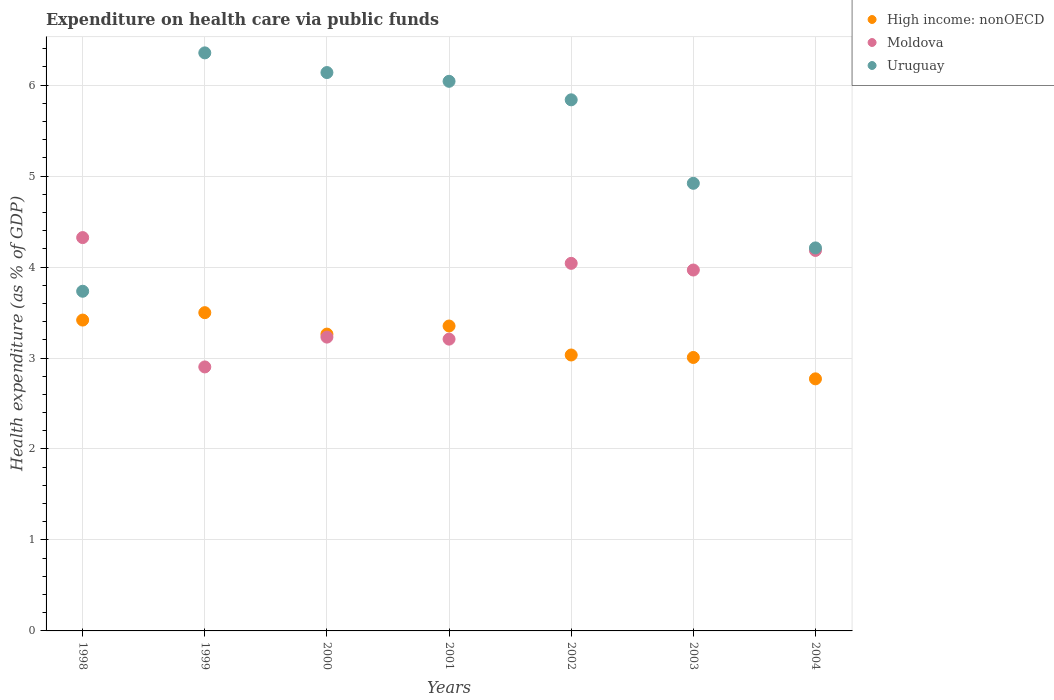What is the expenditure made on health care in Moldova in 2002?
Provide a short and direct response. 4.04. Across all years, what is the maximum expenditure made on health care in Uruguay?
Offer a terse response. 6.35. Across all years, what is the minimum expenditure made on health care in Moldova?
Provide a succinct answer. 2.9. In which year was the expenditure made on health care in Uruguay maximum?
Provide a short and direct response. 1999. In which year was the expenditure made on health care in Moldova minimum?
Give a very brief answer. 1999. What is the total expenditure made on health care in Moldova in the graph?
Your answer should be compact. 25.85. What is the difference between the expenditure made on health care in Uruguay in 2001 and that in 2003?
Provide a short and direct response. 1.12. What is the difference between the expenditure made on health care in High income: nonOECD in 2002 and the expenditure made on health care in Moldova in 2000?
Ensure brevity in your answer.  -0.2. What is the average expenditure made on health care in High income: nonOECD per year?
Offer a terse response. 3.19. In the year 2003, what is the difference between the expenditure made on health care in Uruguay and expenditure made on health care in Moldova?
Provide a succinct answer. 0.95. What is the ratio of the expenditure made on health care in Uruguay in 1998 to that in 2001?
Your response must be concise. 0.62. Is the expenditure made on health care in Moldova in 2001 less than that in 2002?
Keep it short and to the point. Yes. Is the difference between the expenditure made on health care in Uruguay in 1999 and 2003 greater than the difference between the expenditure made on health care in Moldova in 1999 and 2003?
Provide a short and direct response. Yes. What is the difference between the highest and the second highest expenditure made on health care in High income: nonOECD?
Provide a short and direct response. 0.08. What is the difference between the highest and the lowest expenditure made on health care in High income: nonOECD?
Provide a short and direct response. 0.73. In how many years, is the expenditure made on health care in Moldova greater than the average expenditure made on health care in Moldova taken over all years?
Make the answer very short. 4. Is the expenditure made on health care in Uruguay strictly greater than the expenditure made on health care in High income: nonOECD over the years?
Offer a very short reply. Yes. How many years are there in the graph?
Your answer should be compact. 7. What is the difference between two consecutive major ticks on the Y-axis?
Provide a succinct answer. 1. Does the graph contain grids?
Offer a very short reply. Yes. Where does the legend appear in the graph?
Provide a short and direct response. Top right. How many legend labels are there?
Your answer should be very brief. 3. What is the title of the graph?
Your answer should be very brief. Expenditure on health care via public funds. Does "Brunei Darussalam" appear as one of the legend labels in the graph?
Ensure brevity in your answer.  No. What is the label or title of the X-axis?
Offer a terse response. Years. What is the label or title of the Y-axis?
Offer a terse response. Health expenditure (as % of GDP). What is the Health expenditure (as % of GDP) of High income: nonOECD in 1998?
Provide a short and direct response. 3.42. What is the Health expenditure (as % of GDP) of Moldova in 1998?
Offer a very short reply. 4.32. What is the Health expenditure (as % of GDP) in Uruguay in 1998?
Ensure brevity in your answer.  3.73. What is the Health expenditure (as % of GDP) of High income: nonOECD in 1999?
Provide a succinct answer. 3.5. What is the Health expenditure (as % of GDP) in Moldova in 1999?
Offer a terse response. 2.9. What is the Health expenditure (as % of GDP) of Uruguay in 1999?
Offer a terse response. 6.35. What is the Health expenditure (as % of GDP) of High income: nonOECD in 2000?
Make the answer very short. 3.26. What is the Health expenditure (as % of GDP) in Moldova in 2000?
Provide a succinct answer. 3.23. What is the Health expenditure (as % of GDP) of Uruguay in 2000?
Give a very brief answer. 6.14. What is the Health expenditure (as % of GDP) in High income: nonOECD in 2001?
Offer a very short reply. 3.35. What is the Health expenditure (as % of GDP) of Moldova in 2001?
Provide a short and direct response. 3.21. What is the Health expenditure (as % of GDP) of Uruguay in 2001?
Your response must be concise. 6.04. What is the Health expenditure (as % of GDP) of High income: nonOECD in 2002?
Offer a terse response. 3.03. What is the Health expenditure (as % of GDP) of Moldova in 2002?
Keep it short and to the point. 4.04. What is the Health expenditure (as % of GDP) of Uruguay in 2002?
Provide a short and direct response. 5.84. What is the Health expenditure (as % of GDP) in High income: nonOECD in 2003?
Provide a short and direct response. 3.01. What is the Health expenditure (as % of GDP) in Moldova in 2003?
Your answer should be very brief. 3.97. What is the Health expenditure (as % of GDP) of Uruguay in 2003?
Keep it short and to the point. 4.92. What is the Health expenditure (as % of GDP) of High income: nonOECD in 2004?
Offer a very short reply. 2.77. What is the Health expenditure (as % of GDP) in Moldova in 2004?
Your response must be concise. 4.18. What is the Health expenditure (as % of GDP) of Uruguay in 2004?
Give a very brief answer. 4.21. Across all years, what is the maximum Health expenditure (as % of GDP) in High income: nonOECD?
Give a very brief answer. 3.5. Across all years, what is the maximum Health expenditure (as % of GDP) in Moldova?
Offer a very short reply. 4.32. Across all years, what is the maximum Health expenditure (as % of GDP) of Uruguay?
Give a very brief answer. 6.35. Across all years, what is the minimum Health expenditure (as % of GDP) of High income: nonOECD?
Your response must be concise. 2.77. Across all years, what is the minimum Health expenditure (as % of GDP) in Moldova?
Give a very brief answer. 2.9. Across all years, what is the minimum Health expenditure (as % of GDP) in Uruguay?
Your response must be concise. 3.73. What is the total Health expenditure (as % of GDP) of High income: nonOECD in the graph?
Your answer should be very brief. 22.34. What is the total Health expenditure (as % of GDP) in Moldova in the graph?
Keep it short and to the point. 25.85. What is the total Health expenditure (as % of GDP) of Uruguay in the graph?
Your answer should be very brief. 37.24. What is the difference between the Health expenditure (as % of GDP) in High income: nonOECD in 1998 and that in 1999?
Give a very brief answer. -0.08. What is the difference between the Health expenditure (as % of GDP) in Moldova in 1998 and that in 1999?
Give a very brief answer. 1.42. What is the difference between the Health expenditure (as % of GDP) in Uruguay in 1998 and that in 1999?
Your response must be concise. -2.62. What is the difference between the Health expenditure (as % of GDP) in High income: nonOECD in 1998 and that in 2000?
Offer a very short reply. 0.15. What is the difference between the Health expenditure (as % of GDP) in Moldova in 1998 and that in 2000?
Your response must be concise. 1.09. What is the difference between the Health expenditure (as % of GDP) in Uruguay in 1998 and that in 2000?
Offer a terse response. -2.4. What is the difference between the Health expenditure (as % of GDP) in High income: nonOECD in 1998 and that in 2001?
Offer a terse response. 0.07. What is the difference between the Health expenditure (as % of GDP) in Moldova in 1998 and that in 2001?
Your answer should be very brief. 1.12. What is the difference between the Health expenditure (as % of GDP) in Uruguay in 1998 and that in 2001?
Give a very brief answer. -2.31. What is the difference between the Health expenditure (as % of GDP) of High income: nonOECD in 1998 and that in 2002?
Your answer should be very brief. 0.38. What is the difference between the Health expenditure (as % of GDP) in Moldova in 1998 and that in 2002?
Provide a short and direct response. 0.28. What is the difference between the Health expenditure (as % of GDP) of Uruguay in 1998 and that in 2002?
Your answer should be very brief. -2.1. What is the difference between the Health expenditure (as % of GDP) in High income: nonOECD in 1998 and that in 2003?
Keep it short and to the point. 0.41. What is the difference between the Health expenditure (as % of GDP) of Moldova in 1998 and that in 2003?
Provide a succinct answer. 0.36. What is the difference between the Health expenditure (as % of GDP) of Uruguay in 1998 and that in 2003?
Provide a succinct answer. -1.19. What is the difference between the Health expenditure (as % of GDP) in High income: nonOECD in 1998 and that in 2004?
Make the answer very short. 0.65. What is the difference between the Health expenditure (as % of GDP) in Moldova in 1998 and that in 2004?
Provide a short and direct response. 0.14. What is the difference between the Health expenditure (as % of GDP) in Uruguay in 1998 and that in 2004?
Ensure brevity in your answer.  -0.48. What is the difference between the Health expenditure (as % of GDP) of High income: nonOECD in 1999 and that in 2000?
Your response must be concise. 0.24. What is the difference between the Health expenditure (as % of GDP) in Moldova in 1999 and that in 2000?
Offer a terse response. -0.33. What is the difference between the Health expenditure (as % of GDP) in Uruguay in 1999 and that in 2000?
Give a very brief answer. 0.22. What is the difference between the Health expenditure (as % of GDP) in High income: nonOECD in 1999 and that in 2001?
Provide a succinct answer. 0.15. What is the difference between the Health expenditure (as % of GDP) of Moldova in 1999 and that in 2001?
Provide a short and direct response. -0.31. What is the difference between the Health expenditure (as % of GDP) of Uruguay in 1999 and that in 2001?
Ensure brevity in your answer.  0.31. What is the difference between the Health expenditure (as % of GDP) of High income: nonOECD in 1999 and that in 2002?
Provide a short and direct response. 0.47. What is the difference between the Health expenditure (as % of GDP) in Moldova in 1999 and that in 2002?
Provide a short and direct response. -1.14. What is the difference between the Health expenditure (as % of GDP) in Uruguay in 1999 and that in 2002?
Your response must be concise. 0.52. What is the difference between the Health expenditure (as % of GDP) in High income: nonOECD in 1999 and that in 2003?
Give a very brief answer. 0.49. What is the difference between the Health expenditure (as % of GDP) of Moldova in 1999 and that in 2003?
Offer a very short reply. -1.07. What is the difference between the Health expenditure (as % of GDP) in Uruguay in 1999 and that in 2003?
Make the answer very short. 1.43. What is the difference between the Health expenditure (as % of GDP) in High income: nonOECD in 1999 and that in 2004?
Keep it short and to the point. 0.73. What is the difference between the Health expenditure (as % of GDP) in Moldova in 1999 and that in 2004?
Your answer should be compact. -1.28. What is the difference between the Health expenditure (as % of GDP) in Uruguay in 1999 and that in 2004?
Offer a very short reply. 2.14. What is the difference between the Health expenditure (as % of GDP) in High income: nonOECD in 2000 and that in 2001?
Give a very brief answer. -0.09. What is the difference between the Health expenditure (as % of GDP) in Moldova in 2000 and that in 2001?
Give a very brief answer. 0.02. What is the difference between the Health expenditure (as % of GDP) in Uruguay in 2000 and that in 2001?
Give a very brief answer. 0.1. What is the difference between the Health expenditure (as % of GDP) of High income: nonOECD in 2000 and that in 2002?
Keep it short and to the point. 0.23. What is the difference between the Health expenditure (as % of GDP) in Moldova in 2000 and that in 2002?
Provide a succinct answer. -0.81. What is the difference between the Health expenditure (as % of GDP) of Uruguay in 2000 and that in 2002?
Provide a short and direct response. 0.3. What is the difference between the Health expenditure (as % of GDP) in High income: nonOECD in 2000 and that in 2003?
Your answer should be compact. 0.26. What is the difference between the Health expenditure (as % of GDP) of Moldova in 2000 and that in 2003?
Offer a very short reply. -0.74. What is the difference between the Health expenditure (as % of GDP) of Uruguay in 2000 and that in 2003?
Provide a short and direct response. 1.22. What is the difference between the Health expenditure (as % of GDP) of High income: nonOECD in 2000 and that in 2004?
Make the answer very short. 0.49. What is the difference between the Health expenditure (as % of GDP) in Moldova in 2000 and that in 2004?
Your response must be concise. -0.95. What is the difference between the Health expenditure (as % of GDP) in Uruguay in 2000 and that in 2004?
Provide a short and direct response. 1.93. What is the difference between the Health expenditure (as % of GDP) in High income: nonOECD in 2001 and that in 2002?
Your answer should be very brief. 0.32. What is the difference between the Health expenditure (as % of GDP) of Moldova in 2001 and that in 2002?
Your answer should be compact. -0.83. What is the difference between the Health expenditure (as % of GDP) of Uruguay in 2001 and that in 2002?
Ensure brevity in your answer.  0.2. What is the difference between the Health expenditure (as % of GDP) of High income: nonOECD in 2001 and that in 2003?
Give a very brief answer. 0.35. What is the difference between the Health expenditure (as % of GDP) of Moldova in 2001 and that in 2003?
Provide a succinct answer. -0.76. What is the difference between the Health expenditure (as % of GDP) in Uruguay in 2001 and that in 2003?
Offer a terse response. 1.12. What is the difference between the Health expenditure (as % of GDP) in High income: nonOECD in 2001 and that in 2004?
Keep it short and to the point. 0.58. What is the difference between the Health expenditure (as % of GDP) in Moldova in 2001 and that in 2004?
Ensure brevity in your answer.  -0.97. What is the difference between the Health expenditure (as % of GDP) in Uruguay in 2001 and that in 2004?
Your response must be concise. 1.83. What is the difference between the Health expenditure (as % of GDP) in High income: nonOECD in 2002 and that in 2003?
Your answer should be compact. 0.03. What is the difference between the Health expenditure (as % of GDP) in Moldova in 2002 and that in 2003?
Your answer should be compact. 0.07. What is the difference between the Health expenditure (as % of GDP) of Uruguay in 2002 and that in 2003?
Your answer should be very brief. 0.92. What is the difference between the Health expenditure (as % of GDP) in High income: nonOECD in 2002 and that in 2004?
Give a very brief answer. 0.26. What is the difference between the Health expenditure (as % of GDP) of Moldova in 2002 and that in 2004?
Provide a succinct answer. -0.14. What is the difference between the Health expenditure (as % of GDP) in Uruguay in 2002 and that in 2004?
Make the answer very short. 1.63. What is the difference between the Health expenditure (as % of GDP) in High income: nonOECD in 2003 and that in 2004?
Offer a very short reply. 0.23. What is the difference between the Health expenditure (as % of GDP) in Moldova in 2003 and that in 2004?
Offer a terse response. -0.22. What is the difference between the Health expenditure (as % of GDP) of Uruguay in 2003 and that in 2004?
Offer a very short reply. 0.71. What is the difference between the Health expenditure (as % of GDP) in High income: nonOECD in 1998 and the Health expenditure (as % of GDP) in Moldova in 1999?
Your answer should be very brief. 0.52. What is the difference between the Health expenditure (as % of GDP) in High income: nonOECD in 1998 and the Health expenditure (as % of GDP) in Uruguay in 1999?
Keep it short and to the point. -2.94. What is the difference between the Health expenditure (as % of GDP) of Moldova in 1998 and the Health expenditure (as % of GDP) of Uruguay in 1999?
Your answer should be compact. -2.03. What is the difference between the Health expenditure (as % of GDP) of High income: nonOECD in 1998 and the Health expenditure (as % of GDP) of Moldova in 2000?
Give a very brief answer. 0.19. What is the difference between the Health expenditure (as % of GDP) of High income: nonOECD in 1998 and the Health expenditure (as % of GDP) of Uruguay in 2000?
Your answer should be very brief. -2.72. What is the difference between the Health expenditure (as % of GDP) in Moldova in 1998 and the Health expenditure (as % of GDP) in Uruguay in 2000?
Provide a short and direct response. -1.81. What is the difference between the Health expenditure (as % of GDP) in High income: nonOECD in 1998 and the Health expenditure (as % of GDP) in Moldova in 2001?
Offer a very short reply. 0.21. What is the difference between the Health expenditure (as % of GDP) in High income: nonOECD in 1998 and the Health expenditure (as % of GDP) in Uruguay in 2001?
Offer a terse response. -2.62. What is the difference between the Health expenditure (as % of GDP) of Moldova in 1998 and the Health expenditure (as % of GDP) of Uruguay in 2001?
Make the answer very short. -1.72. What is the difference between the Health expenditure (as % of GDP) in High income: nonOECD in 1998 and the Health expenditure (as % of GDP) in Moldova in 2002?
Ensure brevity in your answer.  -0.62. What is the difference between the Health expenditure (as % of GDP) in High income: nonOECD in 1998 and the Health expenditure (as % of GDP) in Uruguay in 2002?
Provide a succinct answer. -2.42. What is the difference between the Health expenditure (as % of GDP) of Moldova in 1998 and the Health expenditure (as % of GDP) of Uruguay in 2002?
Your response must be concise. -1.51. What is the difference between the Health expenditure (as % of GDP) of High income: nonOECD in 1998 and the Health expenditure (as % of GDP) of Moldova in 2003?
Provide a short and direct response. -0.55. What is the difference between the Health expenditure (as % of GDP) of High income: nonOECD in 1998 and the Health expenditure (as % of GDP) of Uruguay in 2003?
Make the answer very short. -1.5. What is the difference between the Health expenditure (as % of GDP) in Moldova in 1998 and the Health expenditure (as % of GDP) in Uruguay in 2003?
Provide a short and direct response. -0.6. What is the difference between the Health expenditure (as % of GDP) in High income: nonOECD in 1998 and the Health expenditure (as % of GDP) in Moldova in 2004?
Your response must be concise. -0.77. What is the difference between the Health expenditure (as % of GDP) of High income: nonOECD in 1998 and the Health expenditure (as % of GDP) of Uruguay in 2004?
Make the answer very short. -0.79. What is the difference between the Health expenditure (as % of GDP) in Moldova in 1998 and the Health expenditure (as % of GDP) in Uruguay in 2004?
Ensure brevity in your answer.  0.11. What is the difference between the Health expenditure (as % of GDP) in High income: nonOECD in 1999 and the Health expenditure (as % of GDP) in Moldova in 2000?
Give a very brief answer. 0.27. What is the difference between the Health expenditure (as % of GDP) in High income: nonOECD in 1999 and the Health expenditure (as % of GDP) in Uruguay in 2000?
Keep it short and to the point. -2.64. What is the difference between the Health expenditure (as % of GDP) of Moldova in 1999 and the Health expenditure (as % of GDP) of Uruguay in 2000?
Offer a terse response. -3.24. What is the difference between the Health expenditure (as % of GDP) of High income: nonOECD in 1999 and the Health expenditure (as % of GDP) of Moldova in 2001?
Keep it short and to the point. 0.29. What is the difference between the Health expenditure (as % of GDP) of High income: nonOECD in 1999 and the Health expenditure (as % of GDP) of Uruguay in 2001?
Provide a short and direct response. -2.54. What is the difference between the Health expenditure (as % of GDP) of Moldova in 1999 and the Health expenditure (as % of GDP) of Uruguay in 2001?
Offer a terse response. -3.14. What is the difference between the Health expenditure (as % of GDP) in High income: nonOECD in 1999 and the Health expenditure (as % of GDP) in Moldova in 2002?
Your answer should be compact. -0.54. What is the difference between the Health expenditure (as % of GDP) in High income: nonOECD in 1999 and the Health expenditure (as % of GDP) in Uruguay in 2002?
Offer a very short reply. -2.34. What is the difference between the Health expenditure (as % of GDP) of Moldova in 1999 and the Health expenditure (as % of GDP) of Uruguay in 2002?
Ensure brevity in your answer.  -2.94. What is the difference between the Health expenditure (as % of GDP) of High income: nonOECD in 1999 and the Health expenditure (as % of GDP) of Moldova in 2003?
Provide a succinct answer. -0.47. What is the difference between the Health expenditure (as % of GDP) in High income: nonOECD in 1999 and the Health expenditure (as % of GDP) in Uruguay in 2003?
Provide a short and direct response. -1.42. What is the difference between the Health expenditure (as % of GDP) of Moldova in 1999 and the Health expenditure (as % of GDP) of Uruguay in 2003?
Provide a short and direct response. -2.02. What is the difference between the Health expenditure (as % of GDP) in High income: nonOECD in 1999 and the Health expenditure (as % of GDP) in Moldova in 2004?
Provide a short and direct response. -0.68. What is the difference between the Health expenditure (as % of GDP) in High income: nonOECD in 1999 and the Health expenditure (as % of GDP) in Uruguay in 2004?
Your answer should be very brief. -0.71. What is the difference between the Health expenditure (as % of GDP) in Moldova in 1999 and the Health expenditure (as % of GDP) in Uruguay in 2004?
Provide a succinct answer. -1.31. What is the difference between the Health expenditure (as % of GDP) in High income: nonOECD in 2000 and the Health expenditure (as % of GDP) in Moldova in 2001?
Your answer should be very brief. 0.06. What is the difference between the Health expenditure (as % of GDP) of High income: nonOECD in 2000 and the Health expenditure (as % of GDP) of Uruguay in 2001?
Your response must be concise. -2.78. What is the difference between the Health expenditure (as % of GDP) of Moldova in 2000 and the Health expenditure (as % of GDP) of Uruguay in 2001?
Your response must be concise. -2.81. What is the difference between the Health expenditure (as % of GDP) of High income: nonOECD in 2000 and the Health expenditure (as % of GDP) of Moldova in 2002?
Your response must be concise. -0.78. What is the difference between the Health expenditure (as % of GDP) of High income: nonOECD in 2000 and the Health expenditure (as % of GDP) of Uruguay in 2002?
Make the answer very short. -2.58. What is the difference between the Health expenditure (as % of GDP) in Moldova in 2000 and the Health expenditure (as % of GDP) in Uruguay in 2002?
Offer a very short reply. -2.61. What is the difference between the Health expenditure (as % of GDP) of High income: nonOECD in 2000 and the Health expenditure (as % of GDP) of Moldova in 2003?
Your answer should be very brief. -0.7. What is the difference between the Health expenditure (as % of GDP) in High income: nonOECD in 2000 and the Health expenditure (as % of GDP) in Uruguay in 2003?
Keep it short and to the point. -1.66. What is the difference between the Health expenditure (as % of GDP) of Moldova in 2000 and the Health expenditure (as % of GDP) of Uruguay in 2003?
Keep it short and to the point. -1.69. What is the difference between the Health expenditure (as % of GDP) in High income: nonOECD in 2000 and the Health expenditure (as % of GDP) in Moldova in 2004?
Keep it short and to the point. -0.92. What is the difference between the Health expenditure (as % of GDP) of High income: nonOECD in 2000 and the Health expenditure (as % of GDP) of Uruguay in 2004?
Your answer should be very brief. -0.95. What is the difference between the Health expenditure (as % of GDP) in Moldova in 2000 and the Health expenditure (as % of GDP) in Uruguay in 2004?
Offer a very short reply. -0.98. What is the difference between the Health expenditure (as % of GDP) in High income: nonOECD in 2001 and the Health expenditure (as % of GDP) in Moldova in 2002?
Offer a very short reply. -0.69. What is the difference between the Health expenditure (as % of GDP) of High income: nonOECD in 2001 and the Health expenditure (as % of GDP) of Uruguay in 2002?
Give a very brief answer. -2.49. What is the difference between the Health expenditure (as % of GDP) in Moldova in 2001 and the Health expenditure (as % of GDP) in Uruguay in 2002?
Ensure brevity in your answer.  -2.63. What is the difference between the Health expenditure (as % of GDP) in High income: nonOECD in 2001 and the Health expenditure (as % of GDP) in Moldova in 2003?
Provide a short and direct response. -0.62. What is the difference between the Health expenditure (as % of GDP) in High income: nonOECD in 2001 and the Health expenditure (as % of GDP) in Uruguay in 2003?
Your response must be concise. -1.57. What is the difference between the Health expenditure (as % of GDP) of Moldova in 2001 and the Health expenditure (as % of GDP) of Uruguay in 2003?
Provide a succinct answer. -1.71. What is the difference between the Health expenditure (as % of GDP) in High income: nonOECD in 2001 and the Health expenditure (as % of GDP) in Moldova in 2004?
Provide a short and direct response. -0.83. What is the difference between the Health expenditure (as % of GDP) of High income: nonOECD in 2001 and the Health expenditure (as % of GDP) of Uruguay in 2004?
Make the answer very short. -0.86. What is the difference between the Health expenditure (as % of GDP) of Moldova in 2001 and the Health expenditure (as % of GDP) of Uruguay in 2004?
Offer a very short reply. -1. What is the difference between the Health expenditure (as % of GDP) of High income: nonOECD in 2002 and the Health expenditure (as % of GDP) of Moldova in 2003?
Provide a succinct answer. -0.93. What is the difference between the Health expenditure (as % of GDP) in High income: nonOECD in 2002 and the Health expenditure (as % of GDP) in Uruguay in 2003?
Your answer should be very brief. -1.89. What is the difference between the Health expenditure (as % of GDP) of Moldova in 2002 and the Health expenditure (as % of GDP) of Uruguay in 2003?
Make the answer very short. -0.88. What is the difference between the Health expenditure (as % of GDP) of High income: nonOECD in 2002 and the Health expenditure (as % of GDP) of Moldova in 2004?
Ensure brevity in your answer.  -1.15. What is the difference between the Health expenditure (as % of GDP) of High income: nonOECD in 2002 and the Health expenditure (as % of GDP) of Uruguay in 2004?
Ensure brevity in your answer.  -1.18. What is the difference between the Health expenditure (as % of GDP) in Moldova in 2002 and the Health expenditure (as % of GDP) in Uruguay in 2004?
Offer a terse response. -0.17. What is the difference between the Health expenditure (as % of GDP) in High income: nonOECD in 2003 and the Health expenditure (as % of GDP) in Moldova in 2004?
Provide a short and direct response. -1.18. What is the difference between the Health expenditure (as % of GDP) in High income: nonOECD in 2003 and the Health expenditure (as % of GDP) in Uruguay in 2004?
Make the answer very short. -1.2. What is the difference between the Health expenditure (as % of GDP) in Moldova in 2003 and the Health expenditure (as % of GDP) in Uruguay in 2004?
Your response must be concise. -0.24. What is the average Health expenditure (as % of GDP) in High income: nonOECD per year?
Ensure brevity in your answer.  3.19. What is the average Health expenditure (as % of GDP) in Moldova per year?
Provide a succinct answer. 3.69. What is the average Health expenditure (as % of GDP) in Uruguay per year?
Ensure brevity in your answer.  5.32. In the year 1998, what is the difference between the Health expenditure (as % of GDP) of High income: nonOECD and Health expenditure (as % of GDP) of Moldova?
Your answer should be very brief. -0.91. In the year 1998, what is the difference between the Health expenditure (as % of GDP) of High income: nonOECD and Health expenditure (as % of GDP) of Uruguay?
Keep it short and to the point. -0.32. In the year 1998, what is the difference between the Health expenditure (as % of GDP) of Moldova and Health expenditure (as % of GDP) of Uruguay?
Make the answer very short. 0.59. In the year 1999, what is the difference between the Health expenditure (as % of GDP) in High income: nonOECD and Health expenditure (as % of GDP) in Moldova?
Provide a succinct answer. 0.6. In the year 1999, what is the difference between the Health expenditure (as % of GDP) of High income: nonOECD and Health expenditure (as % of GDP) of Uruguay?
Provide a short and direct response. -2.86. In the year 1999, what is the difference between the Health expenditure (as % of GDP) of Moldova and Health expenditure (as % of GDP) of Uruguay?
Offer a terse response. -3.45. In the year 2000, what is the difference between the Health expenditure (as % of GDP) in High income: nonOECD and Health expenditure (as % of GDP) in Moldova?
Provide a succinct answer. 0.03. In the year 2000, what is the difference between the Health expenditure (as % of GDP) in High income: nonOECD and Health expenditure (as % of GDP) in Uruguay?
Offer a very short reply. -2.88. In the year 2000, what is the difference between the Health expenditure (as % of GDP) in Moldova and Health expenditure (as % of GDP) in Uruguay?
Give a very brief answer. -2.91. In the year 2001, what is the difference between the Health expenditure (as % of GDP) in High income: nonOECD and Health expenditure (as % of GDP) in Moldova?
Offer a very short reply. 0.14. In the year 2001, what is the difference between the Health expenditure (as % of GDP) of High income: nonOECD and Health expenditure (as % of GDP) of Uruguay?
Your answer should be compact. -2.69. In the year 2001, what is the difference between the Health expenditure (as % of GDP) in Moldova and Health expenditure (as % of GDP) in Uruguay?
Your response must be concise. -2.83. In the year 2002, what is the difference between the Health expenditure (as % of GDP) in High income: nonOECD and Health expenditure (as % of GDP) in Moldova?
Provide a succinct answer. -1.01. In the year 2002, what is the difference between the Health expenditure (as % of GDP) of High income: nonOECD and Health expenditure (as % of GDP) of Uruguay?
Offer a very short reply. -2.81. In the year 2002, what is the difference between the Health expenditure (as % of GDP) of Moldova and Health expenditure (as % of GDP) of Uruguay?
Your response must be concise. -1.8. In the year 2003, what is the difference between the Health expenditure (as % of GDP) of High income: nonOECD and Health expenditure (as % of GDP) of Moldova?
Offer a very short reply. -0.96. In the year 2003, what is the difference between the Health expenditure (as % of GDP) in High income: nonOECD and Health expenditure (as % of GDP) in Uruguay?
Keep it short and to the point. -1.91. In the year 2003, what is the difference between the Health expenditure (as % of GDP) in Moldova and Health expenditure (as % of GDP) in Uruguay?
Ensure brevity in your answer.  -0.95. In the year 2004, what is the difference between the Health expenditure (as % of GDP) of High income: nonOECD and Health expenditure (as % of GDP) of Moldova?
Ensure brevity in your answer.  -1.41. In the year 2004, what is the difference between the Health expenditure (as % of GDP) of High income: nonOECD and Health expenditure (as % of GDP) of Uruguay?
Give a very brief answer. -1.44. In the year 2004, what is the difference between the Health expenditure (as % of GDP) of Moldova and Health expenditure (as % of GDP) of Uruguay?
Provide a short and direct response. -0.03. What is the ratio of the Health expenditure (as % of GDP) in High income: nonOECD in 1998 to that in 1999?
Your answer should be very brief. 0.98. What is the ratio of the Health expenditure (as % of GDP) of Moldova in 1998 to that in 1999?
Your answer should be very brief. 1.49. What is the ratio of the Health expenditure (as % of GDP) of Uruguay in 1998 to that in 1999?
Give a very brief answer. 0.59. What is the ratio of the Health expenditure (as % of GDP) in High income: nonOECD in 1998 to that in 2000?
Provide a short and direct response. 1.05. What is the ratio of the Health expenditure (as % of GDP) of Moldova in 1998 to that in 2000?
Ensure brevity in your answer.  1.34. What is the ratio of the Health expenditure (as % of GDP) of Uruguay in 1998 to that in 2000?
Make the answer very short. 0.61. What is the ratio of the Health expenditure (as % of GDP) of High income: nonOECD in 1998 to that in 2001?
Give a very brief answer. 1.02. What is the ratio of the Health expenditure (as % of GDP) in Moldova in 1998 to that in 2001?
Offer a very short reply. 1.35. What is the ratio of the Health expenditure (as % of GDP) in Uruguay in 1998 to that in 2001?
Offer a terse response. 0.62. What is the ratio of the Health expenditure (as % of GDP) in High income: nonOECD in 1998 to that in 2002?
Your answer should be compact. 1.13. What is the ratio of the Health expenditure (as % of GDP) of Moldova in 1998 to that in 2002?
Your answer should be compact. 1.07. What is the ratio of the Health expenditure (as % of GDP) of Uruguay in 1998 to that in 2002?
Provide a short and direct response. 0.64. What is the ratio of the Health expenditure (as % of GDP) in High income: nonOECD in 1998 to that in 2003?
Provide a succinct answer. 1.14. What is the ratio of the Health expenditure (as % of GDP) in Moldova in 1998 to that in 2003?
Give a very brief answer. 1.09. What is the ratio of the Health expenditure (as % of GDP) in Uruguay in 1998 to that in 2003?
Your answer should be very brief. 0.76. What is the ratio of the Health expenditure (as % of GDP) of High income: nonOECD in 1998 to that in 2004?
Provide a short and direct response. 1.23. What is the ratio of the Health expenditure (as % of GDP) of Moldova in 1998 to that in 2004?
Your response must be concise. 1.03. What is the ratio of the Health expenditure (as % of GDP) in Uruguay in 1998 to that in 2004?
Offer a terse response. 0.89. What is the ratio of the Health expenditure (as % of GDP) in High income: nonOECD in 1999 to that in 2000?
Provide a succinct answer. 1.07. What is the ratio of the Health expenditure (as % of GDP) of Moldova in 1999 to that in 2000?
Your answer should be very brief. 0.9. What is the ratio of the Health expenditure (as % of GDP) in Uruguay in 1999 to that in 2000?
Your answer should be compact. 1.04. What is the ratio of the Health expenditure (as % of GDP) of High income: nonOECD in 1999 to that in 2001?
Offer a terse response. 1.04. What is the ratio of the Health expenditure (as % of GDP) of Moldova in 1999 to that in 2001?
Make the answer very short. 0.9. What is the ratio of the Health expenditure (as % of GDP) of Uruguay in 1999 to that in 2001?
Provide a short and direct response. 1.05. What is the ratio of the Health expenditure (as % of GDP) of High income: nonOECD in 1999 to that in 2002?
Make the answer very short. 1.15. What is the ratio of the Health expenditure (as % of GDP) of Moldova in 1999 to that in 2002?
Your answer should be compact. 0.72. What is the ratio of the Health expenditure (as % of GDP) in Uruguay in 1999 to that in 2002?
Your answer should be very brief. 1.09. What is the ratio of the Health expenditure (as % of GDP) of High income: nonOECD in 1999 to that in 2003?
Ensure brevity in your answer.  1.16. What is the ratio of the Health expenditure (as % of GDP) of Moldova in 1999 to that in 2003?
Give a very brief answer. 0.73. What is the ratio of the Health expenditure (as % of GDP) in Uruguay in 1999 to that in 2003?
Your response must be concise. 1.29. What is the ratio of the Health expenditure (as % of GDP) of High income: nonOECD in 1999 to that in 2004?
Provide a short and direct response. 1.26. What is the ratio of the Health expenditure (as % of GDP) of Moldova in 1999 to that in 2004?
Keep it short and to the point. 0.69. What is the ratio of the Health expenditure (as % of GDP) of Uruguay in 1999 to that in 2004?
Offer a terse response. 1.51. What is the ratio of the Health expenditure (as % of GDP) in High income: nonOECD in 2000 to that in 2001?
Your response must be concise. 0.97. What is the ratio of the Health expenditure (as % of GDP) in Moldova in 2000 to that in 2001?
Your response must be concise. 1.01. What is the ratio of the Health expenditure (as % of GDP) in Uruguay in 2000 to that in 2001?
Make the answer very short. 1.02. What is the ratio of the Health expenditure (as % of GDP) in High income: nonOECD in 2000 to that in 2002?
Give a very brief answer. 1.08. What is the ratio of the Health expenditure (as % of GDP) of Moldova in 2000 to that in 2002?
Offer a very short reply. 0.8. What is the ratio of the Health expenditure (as % of GDP) of Uruguay in 2000 to that in 2002?
Your response must be concise. 1.05. What is the ratio of the Health expenditure (as % of GDP) in High income: nonOECD in 2000 to that in 2003?
Offer a very short reply. 1.09. What is the ratio of the Health expenditure (as % of GDP) in Moldova in 2000 to that in 2003?
Your response must be concise. 0.81. What is the ratio of the Health expenditure (as % of GDP) of Uruguay in 2000 to that in 2003?
Offer a terse response. 1.25. What is the ratio of the Health expenditure (as % of GDP) in High income: nonOECD in 2000 to that in 2004?
Give a very brief answer. 1.18. What is the ratio of the Health expenditure (as % of GDP) in Moldova in 2000 to that in 2004?
Your answer should be compact. 0.77. What is the ratio of the Health expenditure (as % of GDP) in Uruguay in 2000 to that in 2004?
Your response must be concise. 1.46. What is the ratio of the Health expenditure (as % of GDP) in High income: nonOECD in 2001 to that in 2002?
Offer a terse response. 1.11. What is the ratio of the Health expenditure (as % of GDP) in Moldova in 2001 to that in 2002?
Make the answer very short. 0.79. What is the ratio of the Health expenditure (as % of GDP) in Uruguay in 2001 to that in 2002?
Ensure brevity in your answer.  1.03. What is the ratio of the Health expenditure (as % of GDP) in High income: nonOECD in 2001 to that in 2003?
Offer a terse response. 1.12. What is the ratio of the Health expenditure (as % of GDP) of Moldova in 2001 to that in 2003?
Make the answer very short. 0.81. What is the ratio of the Health expenditure (as % of GDP) in Uruguay in 2001 to that in 2003?
Provide a short and direct response. 1.23. What is the ratio of the Health expenditure (as % of GDP) of High income: nonOECD in 2001 to that in 2004?
Provide a succinct answer. 1.21. What is the ratio of the Health expenditure (as % of GDP) in Moldova in 2001 to that in 2004?
Ensure brevity in your answer.  0.77. What is the ratio of the Health expenditure (as % of GDP) of Uruguay in 2001 to that in 2004?
Give a very brief answer. 1.44. What is the ratio of the Health expenditure (as % of GDP) of High income: nonOECD in 2002 to that in 2003?
Your answer should be very brief. 1.01. What is the ratio of the Health expenditure (as % of GDP) in Moldova in 2002 to that in 2003?
Keep it short and to the point. 1.02. What is the ratio of the Health expenditure (as % of GDP) of Uruguay in 2002 to that in 2003?
Provide a short and direct response. 1.19. What is the ratio of the Health expenditure (as % of GDP) of High income: nonOECD in 2002 to that in 2004?
Provide a succinct answer. 1.09. What is the ratio of the Health expenditure (as % of GDP) in Moldova in 2002 to that in 2004?
Make the answer very short. 0.97. What is the ratio of the Health expenditure (as % of GDP) in Uruguay in 2002 to that in 2004?
Give a very brief answer. 1.39. What is the ratio of the Health expenditure (as % of GDP) of High income: nonOECD in 2003 to that in 2004?
Your response must be concise. 1.08. What is the ratio of the Health expenditure (as % of GDP) in Moldova in 2003 to that in 2004?
Your answer should be very brief. 0.95. What is the ratio of the Health expenditure (as % of GDP) of Uruguay in 2003 to that in 2004?
Offer a terse response. 1.17. What is the difference between the highest and the second highest Health expenditure (as % of GDP) of High income: nonOECD?
Your answer should be compact. 0.08. What is the difference between the highest and the second highest Health expenditure (as % of GDP) of Moldova?
Offer a very short reply. 0.14. What is the difference between the highest and the second highest Health expenditure (as % of GDP) of Uruguay?
Your answer should be very brief. 0.22. What is the difference between the highest and the lowest Health expenditure (as % of GDP) of High income: nonOECD?
Offer a terse response. 0.73. What is the difference between the highest and the lowest Health expenditure (as % of GDP) of Moldova?
Provide a succinct answer. 1.42. What is the difference between the highest and the lowest Health expenditure (as % of GDP) in Uruguay?
Ensure brevity in your answer.  2.62. 